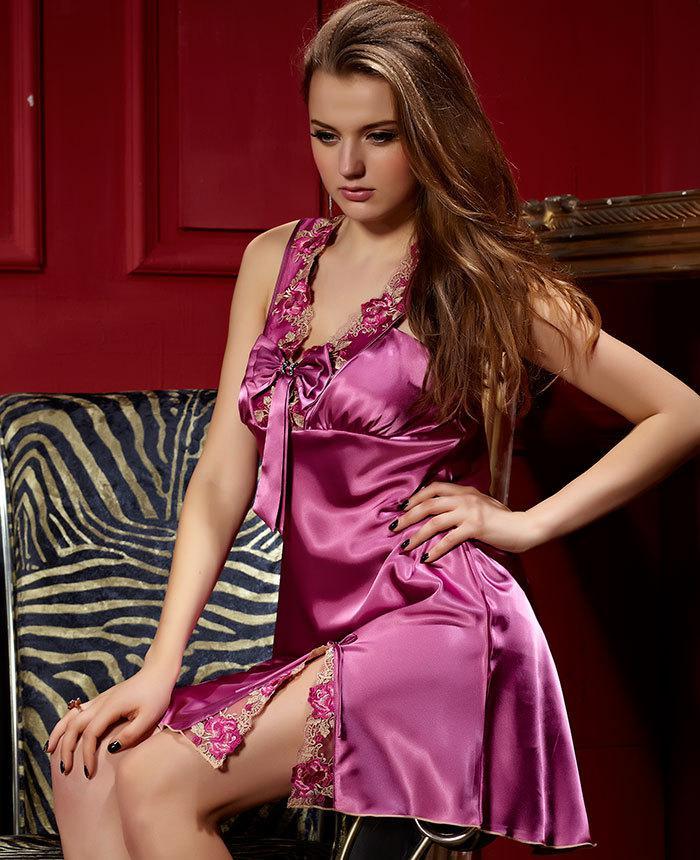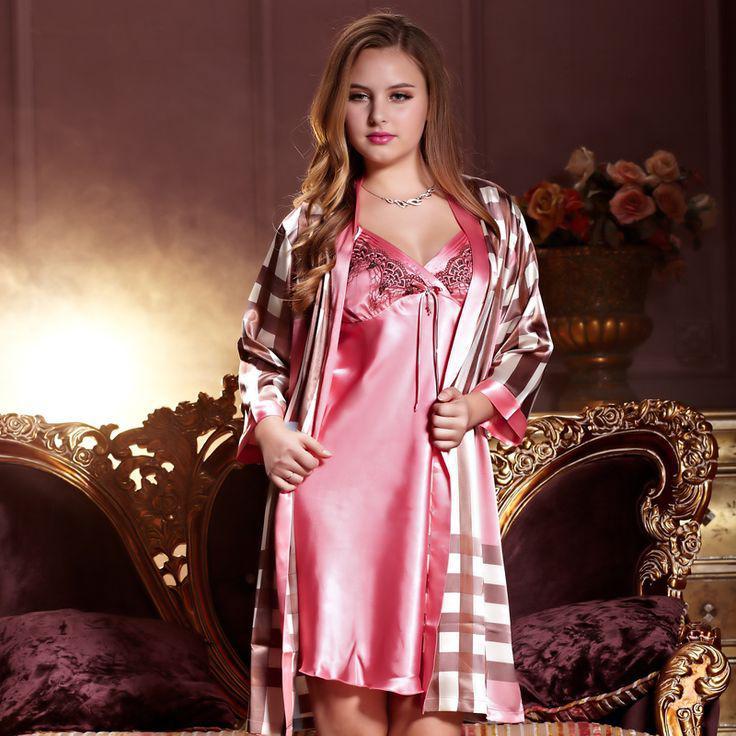The first image is the image on the left, the second image is the image on the right. For the images displayed, is the sentence "One woman is sitting on something." factually correct? Answer yes or no. Yes. The first image is the image on the left, the second image is the image on the right. For the images displayed, is the sentence "In one of the images, the girl is sitting down" factually correct? Answer yes or no. Yes. 